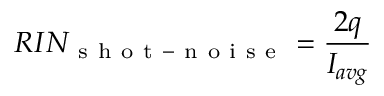<formula> <loc_0><loc_0><loc_500><loc_500>R I N _ { s h o t - n o i s e } = \frac { 2 q } { I _ { a v g } }</formula> 